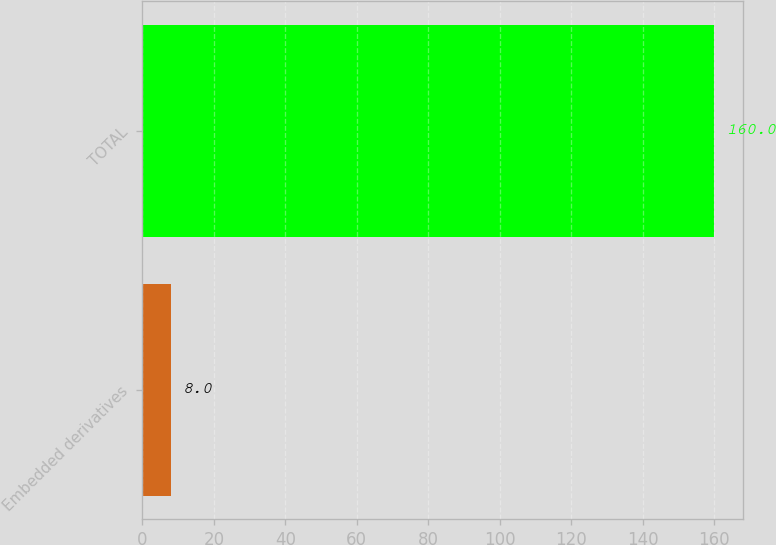<chart> <loc_0><loc_0><loc_500><loc_500><bar_chart><fcel>Embedded derivatives<fcel>TOTAL<nl><fcel>8<fcel>160<nl></chart> 